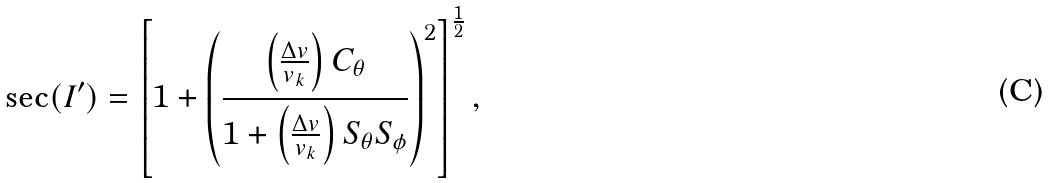<formula> <loc_0><loc_0><loc_500><loc_500>\sec ( I ^ { \prime } ) = \left [ 1 + \left ( \frac { \left ( \frac { \Delta v } { v _ { k } } \right ) C _ { \theta } } { 1 + \left ( \frac { \Delta v } { v _ { k } } \right ) S _ { \theta } S _ { \phi } } \right ) ^ { 2 } \right ] ^ { \frac { 1 } { 2 } } ,</formula> 